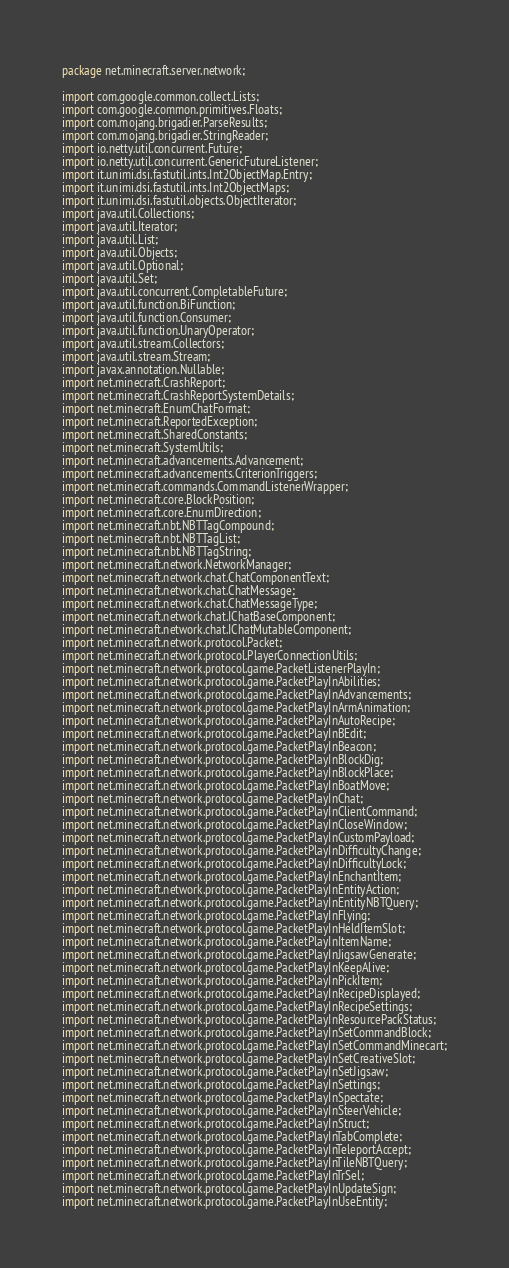<code> <loc_0><loc_0><loc_500><loc_500><_Java_>package net.minecraft.server.network;

import com.google.common.collect.Lists;
import com.google.common.primitives.Floats;
import com.mojang.brigadier.ParseResults;
import com.mojang.brigadier.StringReader;
import io.netty.util.concurrent.Future;
import io.netty.util.concurrent.GenericFutureListener;
import it.unimi.dsi.fastutil.ints.Int2ObjectMap.Entry;
import it.unimi.dsi.fastutil.ints.Int2ObjectMaps;
import it.unimi.dsi.fastutil.objects.ObjectIterator;
import java.util.Collections;
import java.util.Iterator;
import java.util.List;
import java.util.Objects;
import java.util.Optional;
import java.util.Set;
import java.util.concurrent.CompletableFuture;
import java.util.function.BiFunction;
import java.util.function.Consumer;
import java.util.function.UnaryOperator;
import java.util.stream.Collectors;
import java.util.stream.Stream;
import javax.annotation.Nullable;
import net.minecraft.CrashReport;
import net.minecraft.CrashReportSystemDetails;
import net.minecraft.EnumChatFormat;
import net.minecraft.ReportedException;
import net.minecraft.SharedConstants;
import net.minecraft.SystemUtils;
import net.minecraft.advancements.Advancement;
import net.minecraft.advancements.CriterionTriggers;
import net.minecraft.commands.CommandListenerWrapper;
import net.minecraft.core.BlockPosition;
import net.minecraft.core.EnumDirection;
import net.minecraft.nbt.NBTTagCompound;
import net.minecraft.nbt.NBTTagList;
import net.minecraft.nbt.NBTTagString;
import net.minecraft.network.NetworkManager;
import net.minecraft.network.chat.ChatComponentText;
import net.minecraft.network.chat.ChatMessage;
import net.minecraft.network.chat.ChatMessageType;
import net.minecraft.network.chat.IChatBaseComponent;
import net.minecraft.network.chat.IChatMutableComponent;
import net.minecraft.network.protocol.Packet;
import net.minecraft.network.protocol.PlayerConnectionUtils;
import net.minecraft.network.protocol.game.PacketListenerPlayIn;
import net.minecraft.network.protocol.game.PacketPlayInAbilities;
import net.minecraft.network.protocol.game.PacketPlayInAdvancements;
import net.minecraft.network.protocol.game.PacketPlayInArmAnimation;
import net.minecraft.network.protocol.game.PacketPlayInAutoRecipe;
import net.minecraft.network.protocol.game.PacketPlayInBEdit;
import net.minecraft.network.protocol.game.PacketPlayInBeacon;
import net.minecraft.network.protocol.game.PacketPlayInBlockDig;
import net.minecraft.network.protocol.game.PacketPlayInBlockPlace;
import net.minecraft.network.protocol.game.PacketPlayInBoatMove;
import net.minecraft.network.protocol.game.PacketPlayInChat;
import net.minecraft.network.protocol.game.PacketPlayInClientCommand;
import net.minecraft.network.protocol.game.PacketPlayInCloseWindow;
import net.minecraft.network.protocol.game.PacketPlayInCustomPayload;
import net.minecraft.network.protocol.game.PacketPlayInDifficultyChange;
import net.minecraft.network.protocol.game.PacketPlayInDifficultyLock;
import net.minecraft.network.protocol.game.PacketPlayInEnchantItem;
import net.minecraft.network.protocol.game.PacketPlayInEntityAction;
import net.minecraft.network.protocol.game.PacketPlayInEntityNBTQuery;
import net.minecraft.network.protocol.game.PacketPlayInFlying;
import net.minecraft.network.protocol.game.PacketPlayInHeldItemSlot;
import net.minecraft.network.protocol.game.PacketPlayInItemName;
import net.minecraft.network.protocol.game.PacketPlayInJigsawGenerate;
import net.minecraft.network.protocol.game.PacketPlayInKeepAlive;
import net.minecraft.network.protocol.game.PacketPlayInPickItem;
import net.minecraft.network.protocol.game.PacketPlayInRecipeDisplayed;
import net.minecraft.network.protocol.game.PacketPlayInRecipeSettings;
import net.minecraft.network.protocol.game.PacketPlayInResourcePackStatus;
import net.minecraft.network.protocol.game.PacketPlayInSetCommandBlock;
import net.minecraft.network.protocol.game.PacketPlayInSetCommandMinecart;
import net.minecraft.network.protocol.game.PacketPlayInSetCreativeSlot;
import net.minecraft.network.protocol.game.PacketPlayInSetJigsaw;
import net.minecraft.network.protocol.game.PacketPlayInSettings;
import net.minecraft.network.protocol.game.PacketPlayInSpectate;
import net.minecraft.network.protocol.game.PacketPlayInSteerVehicle;
import net.minecraft.network.protocol.game.PacketPlayInStruct;
import net.minecraft.network.protocol.game.PacketPlayInTabComplete;
import net.minecraft.network.protocol.game.PacketPlayInTeleportAccept;
import net.minecraft.network.protocol.game.PacketPlayInTileNBTQuery;
import net.minecraft.network.protocol.game.PacketPlayInTrSel;
import net.minecraft.network.protocol.game.PacketPlayInUpdateSign;
import net.minecraft.network.protocol.game.PacketPlayInUseEntity;</code> 